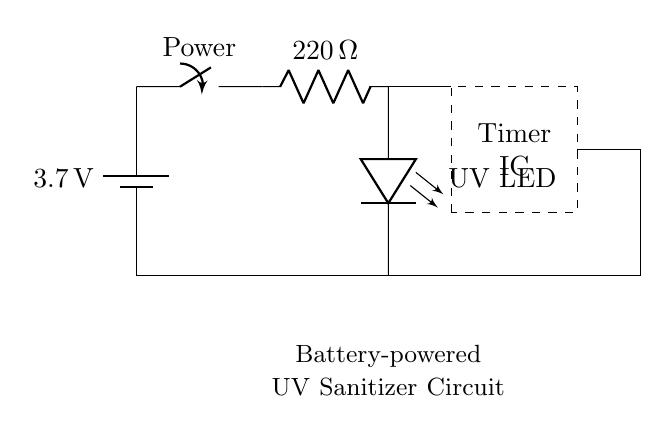What is the voltage of the battery? The voltage of the battery is indicated on the diagram as 3.7 volts, which is clearly labeled next to the battery symbol.
Answer: 3.7 volts What is the value of the resistor? The resistor is labeled in the circuit diagram with a value of 220 ohms, which can be seen directly on the resistor symbol.
Answer: 220 ohms Which type of LED is used in the circuit? The circuit diagram specifies that the LED used is a UV LED, which is labeled beside the LED symbol in the diagram.
Answer: UV LED What is the purpose of the timer IC? The timer IC in the circuit is used to control the operation of the UV LED, which allows for timed disinfection. This can be inferred from its position and typical usage in similar circuits.
Answer: Control How does the circuit complete its loop? The circuit completes its loop by connecting the negative terminal of the battery to the UV LED, which then connects back to the positive terminal, creating a closed path for current flow.
Answer: Closed loop What type of switch is used? The switch used in the circuit is a mechanical switch, as denoted in the circuit diagram, allowing or interrupting the flow of current when toggled.
Answer: Mechanical switch What is the purpose of the UV sanitizer circuit? The purpose of the UV sanitizer circuit is to disinfect personal items using ultraviolet light emitted from the UV LED, which is its primary function indicated in the circuit.
Answer: Disinfect personal items 